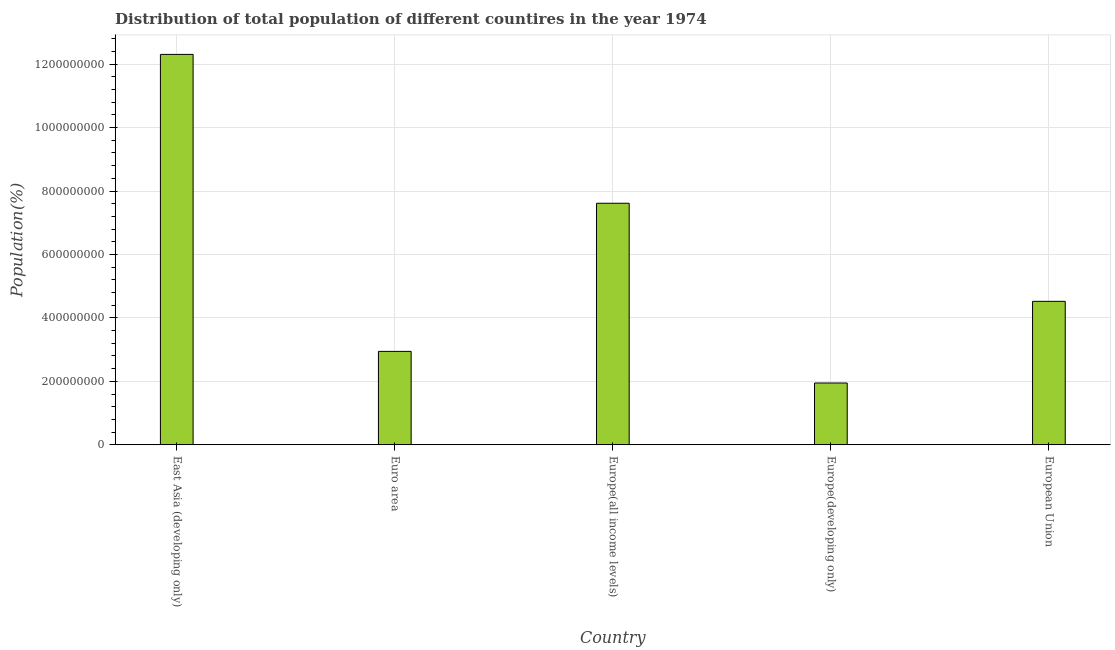Does the graph contain any zero values?
Your answer should be very brief. No. What is the title of the graph?
Ensure brevity in your answer.  Distribution of total population of different countires in the year 1974. What is the label or title of the Y-axis?
Provide a short and direct response. Population(%). What is the population in Europe(developing only)?
Provide a succinct answer. 1.95e+08. Across all countries, what is the maximum population?
Your answer should be very brief. 1.23e+09. Across all countries, what is the minimum population?
Ensure brevity in your answer.  1.95e+08. In which country was the population maximum?
Provide a succinct answer. East Asia (developing only). In which country was the population minimum?
Provide a short and direct response. Europe(developing only). What is the sum of the population?
Make the answer very short. 2.93e+09. What is the difference between the population in Euro area and European Union?
Ensure brevity in your answer.  -1.58e+08. What is the average population per country?
Offer a very short reply. 5.87e+08. What is the median population?
Give a very brief answer. 4.52e+08. What is the ratio of the population in Euro area to that in European Union?
Keep it short and to the point. 0.65. Is the population in East Asia (developing only) less than that in European Union?
Your answer should be compact. No. What is the difference between the highest and the second highest population?
Offer a very short reply. 4.69e+08. What is the difference between the highest and the lowest population?
Provide a succinct answer. 1.04e+09. In how many countries, is the population greater than the average population taken over all countries?
Your answer should be very brief. 2. Are all the bars in the graph horizontal?
Give a very brief answer. No. How many countries are there in the graph?
Your response must be concise. 5. Are the values on the major ticks of Y-axis written in scientific E-notation?
Provide a short and direct response. No. What is the Population(%) in East Asia (developing only)?
Make the answer very short. 1.23e+09. What is the Population(%) in Euro area?
Provide a short and direct response. 2.94e+08. What is the Population(%) in Europe(all income levels)?
Your response must be concise. 7.61e+08. What is the Population(%) of Europe(developing only)?
Offer a terse response. 1.95e+08. What is the Population(%) in European Union?
Provide a short and direct response. 4.52e+08. What is the difference between the Population(%) in East Asia (developing only) and Euro area?
Give a very brief answer. 9.36e+08. What is the difference between the Population(%) in East Asia (developing only) and Europe(all income levels)?
Ensure brevity in your answer.  4.69e+08. What is the difference between the Population(%) in East Asia (developing only) and Europe(developing only)?
Make the answer very short. 1.04e+09. What is the difference between the Population(%) in East Asia (developing only) and European Union?
Your answer should be compact. 7.78e+08. What is the difference between the Population(%) in Euro area and Europe(all income levels)?
Your answer should be very brief. -4.67e+08. What is the difference between the Population(%) in Euro area and Europe(developing only)?
Keep it short and to the point. 9.96e+07. What is the difference between the Population(%) in Euro area and European Union?
Provide a succinct answer. -1.58e+08. What is the difference between the Population(%) in Europe(all income levels) and Europe(developing only)?
Your response must be concise. 5.67e+08. What is the difference between the Population(%) in Europe(all income levels) and European Union?
Your response must be concise. 3.09e+08. What is the difference between the Population(%) in Europe(developing only) and European Union?
Provide a short and direct response. -2.57e+08. What is the ratio of the Population(%) in East Asia (developing only) to that in Euro area?
Provide a succinct answer. 4.18. What is the ratio of the Population(%) in East Asia (developing only) to that in Europe(all income levels)?
Your answer should be very brief. 1.62. What is the ratio of the Population(%) in East Asia (developing only) to that in Europe(developing only)?
Provide a short and direct response. 6.32. What is the ratio of the Population(%) in East Asia (developing only) to that in European Union?
Offer a very short reply. 2.72. What is the ratio of the Population(%) in Euro area to that in Europe(all income levels)?
Give a very brief answer. 0.39. What is the ratio of the Population(%) in Euro area to that in Europe(developing only)?
Make the answer very short. 1.51. What is the ratio of the Population(%) in Euro area to that in European Union?
Your response must be concise. 0.65. What is the ratio of the Population(%) in Europe(all income levels) to that in Europe(developing only)?
Your answer should be very brief. 3.91. What is the ratio of the Population(%) in Europe(all income levels) to that in European Union?
Give a very brief answer. 1.68. What is the ratio of the Population(%) in Europe(developing only) to that in European Union?
Your answer should be very brief. 0.43. 